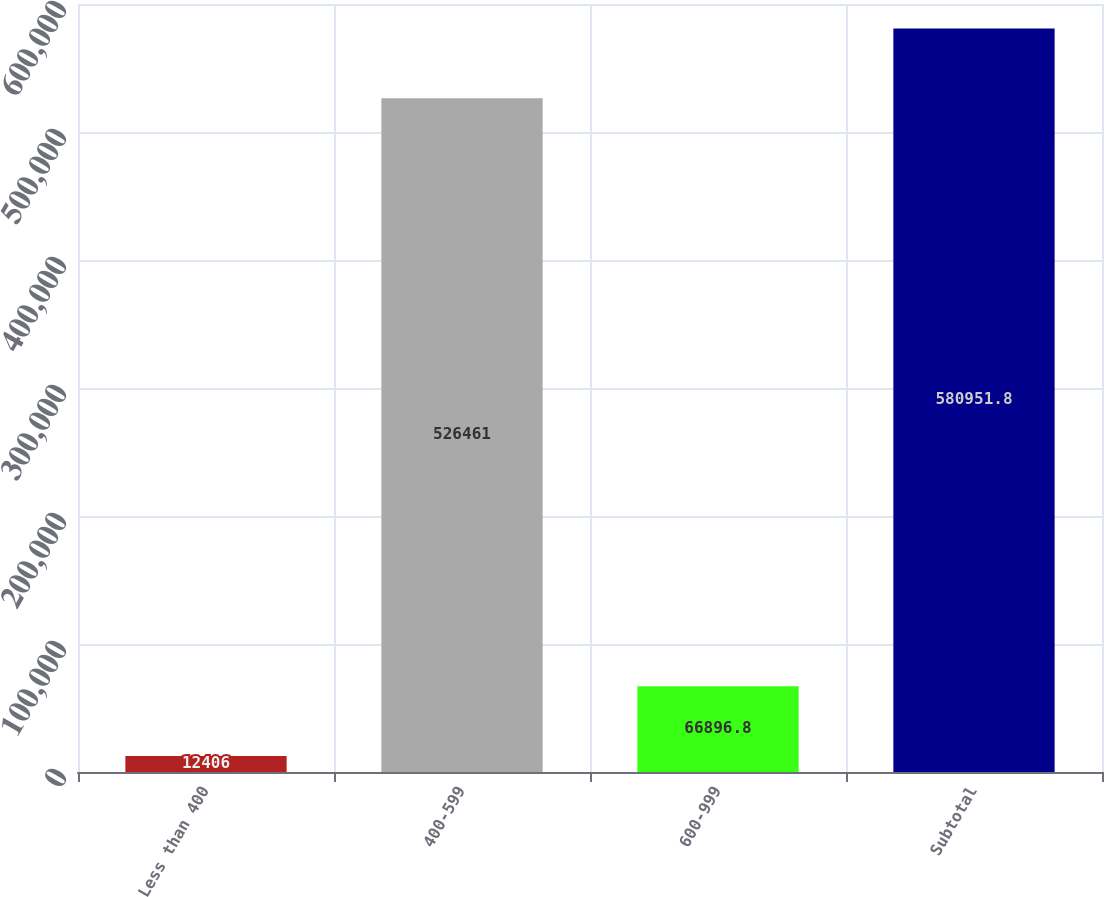Convert chart to OTSL. <chart><loc_0><loc_0><loc_500><loc_500><bar_chart><fcel>Less than 400<fcel>400-599<fcel>600-999<fcel>Subtotal<nl><fcel>12406<fcel>526461<fcel>66896.8<fcel>580952<nl></chart> 